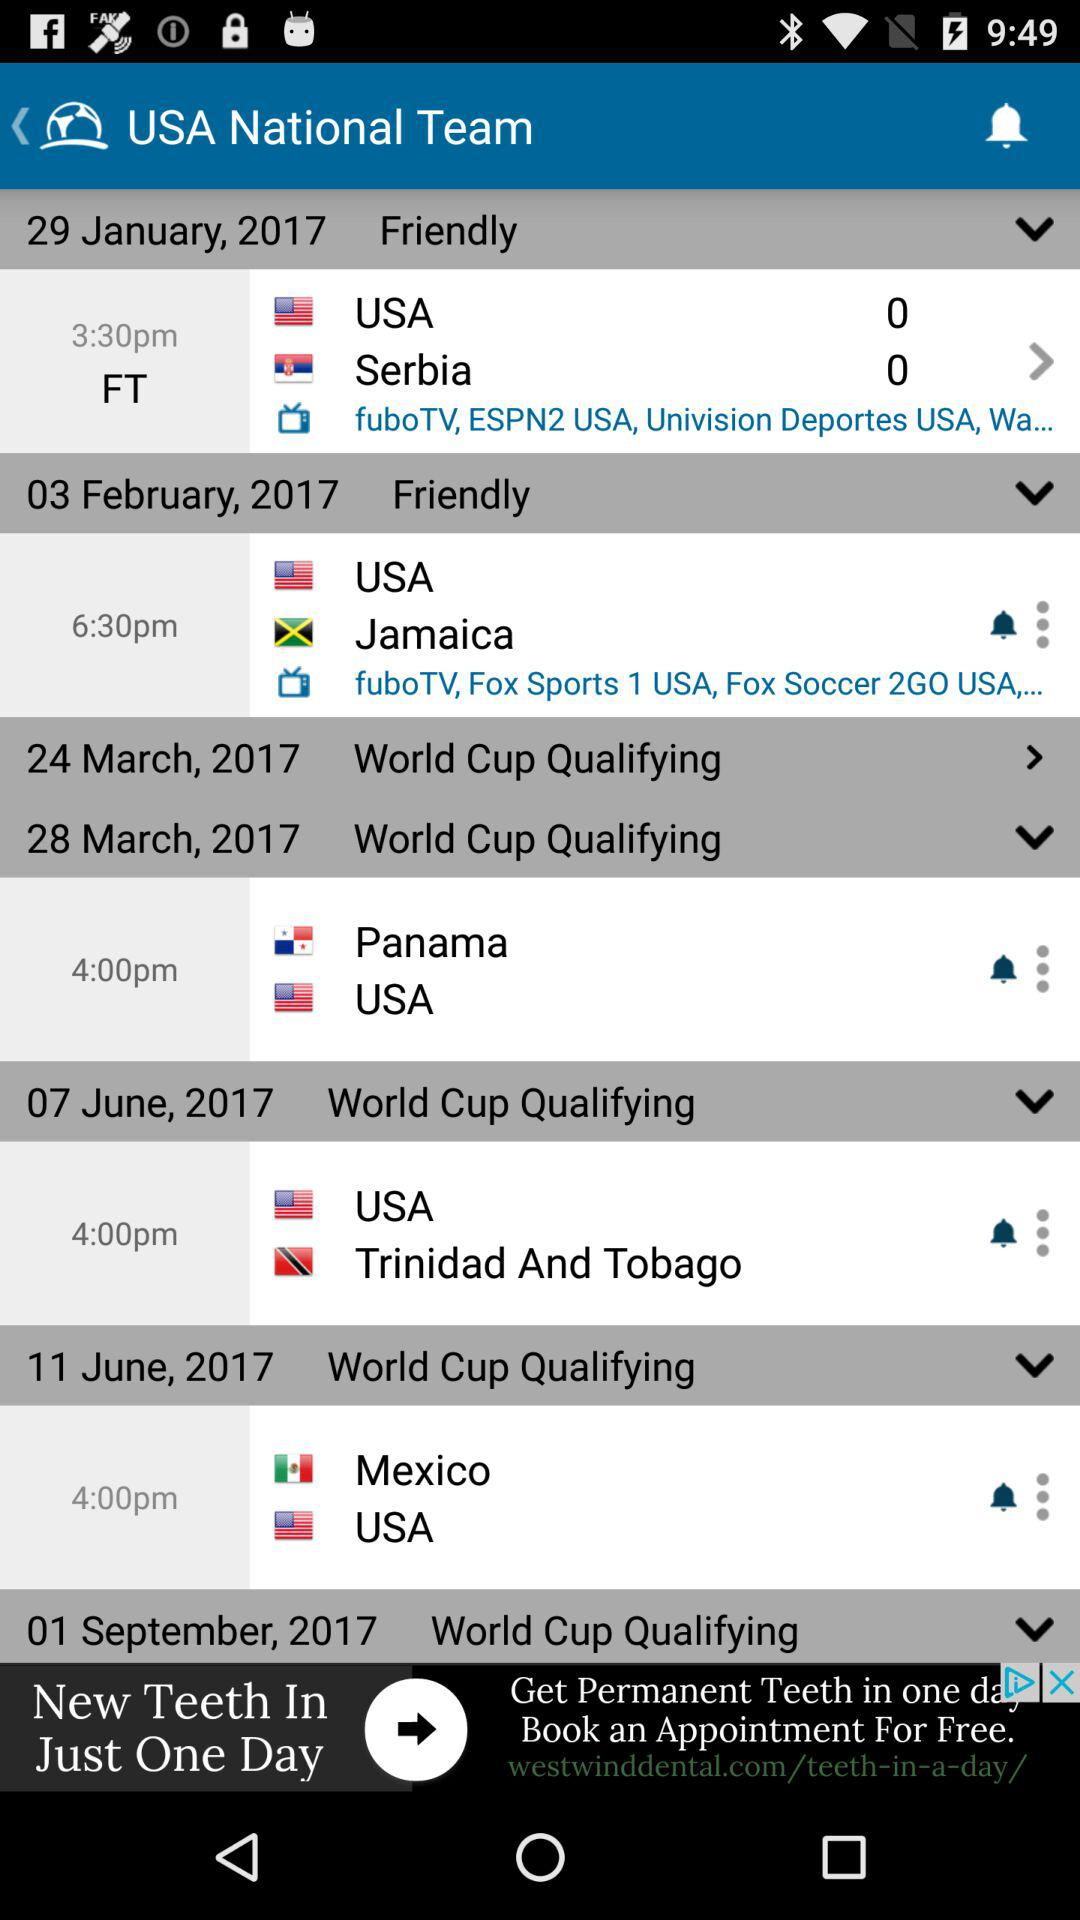What is the time of the match on February 3rd? The time is 6:30 p.m. 